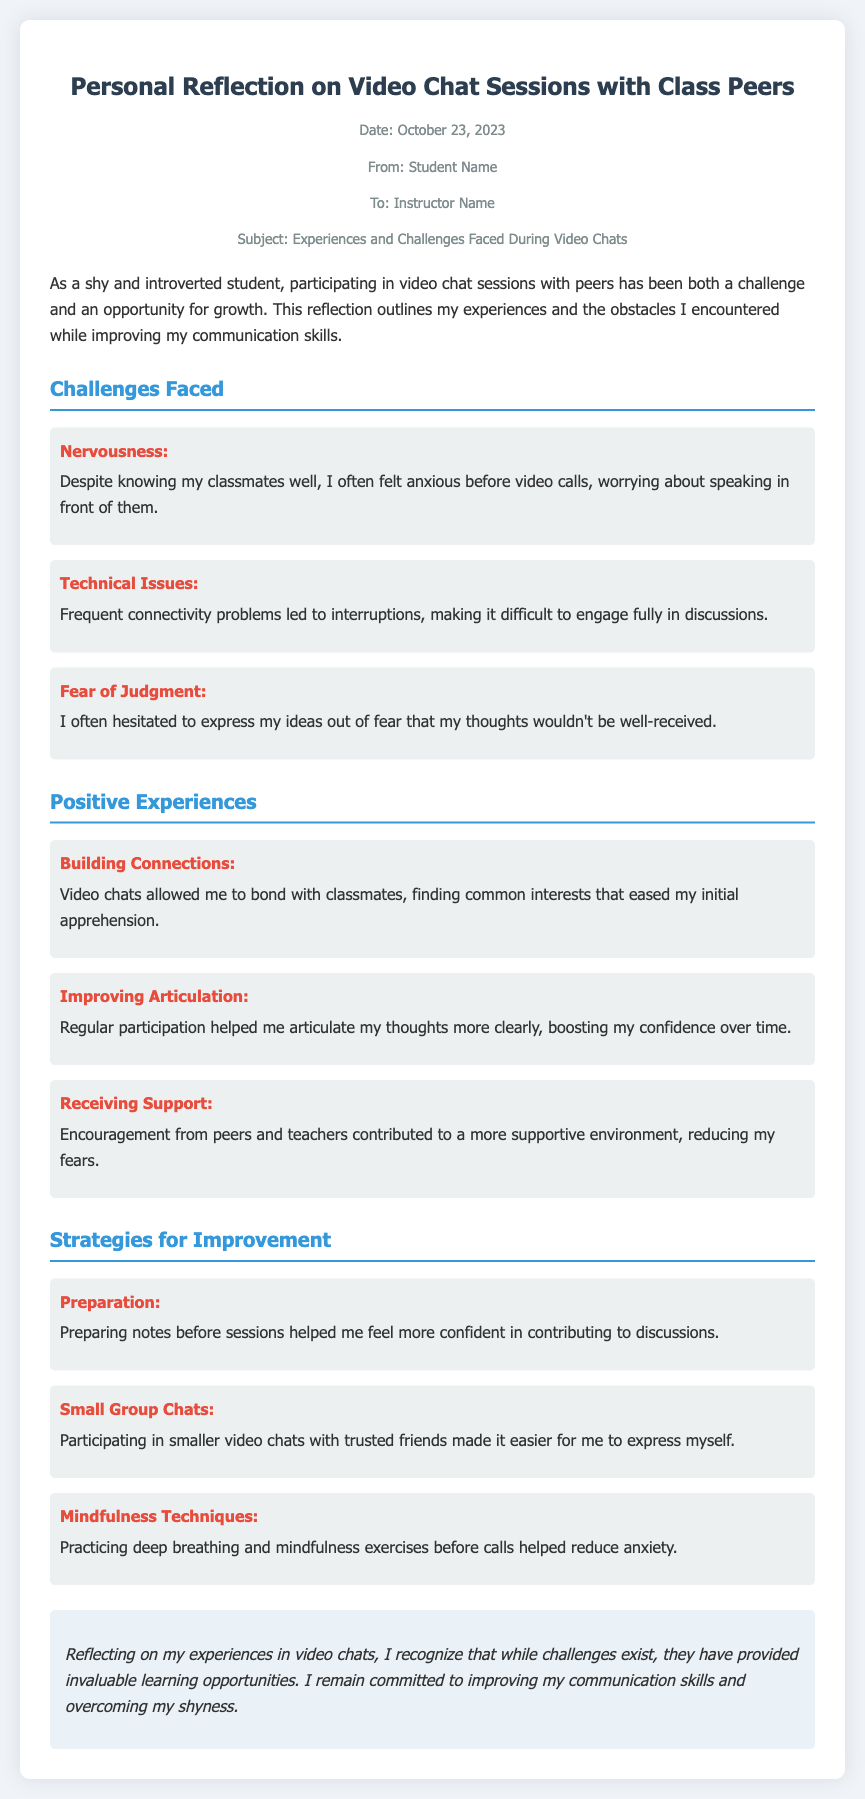What is the date of the memo? The date of the memo is stated in the meta section, which specifies when the reflection was written.
Answer: October 23, 2023 Who is the memo addressed to? The recipient of the memo is identified in the meta section under "To".
Answer: Instructor Name What is one of the challenges faced during video chat sessions? The memo lists several challenges; each is followed by a description in the challenges section.
Answer: Nervousness What strategy was used to improve communication skills? One of the strategies mentioned in the document helps the student feel more prepared for discussions.
Answer: Preparation How did video chats help in building connections? The document describes positive experiences and mentions specific benefits related to bonding.
Answer: Finding common interests What did regular participation in video chats help improve? The memo states the benefit gained from regular involvement in discussions regarding self-expression.
Answer: Articulation How did mindfulness techniques help reduce anxiety? Mindfulness techniques are mentioned in the strategies section as aiding in managing nervousness before calls.
Answer: By practicing deep breathing Which aspect did the student feel was a positive outcome of receiving support? The reflection highlights the impact of encouragement from peers and teachers in the context of overcoming fears.
Answer: A more supportive environment What section follows the 'Challenges Faced' section? The structure of the memo follows a clear order; identifying which section comes next can provide insight into the flow of ideas presented.
Answer: Positive Experiences 